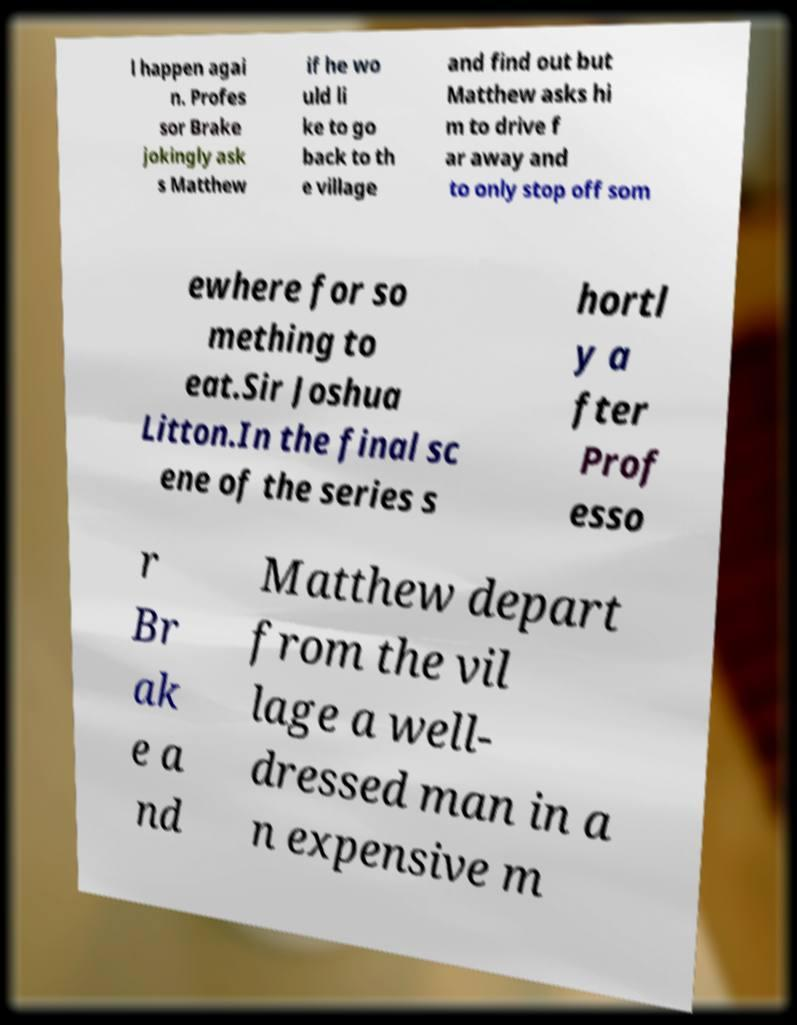There's text embedded in this image that I need extracted. Can you transcribe it verbatim? l happen agai n. Profes sor Brake jokingly ask s Matthew if he wo uld li ke to go back to th e village and find out but Matthew asks hi m to drive f ar away and to only stop off som ewhere for so mething to eat.Sir Joshua Litton.In the final sc ene of the series s hortl y a fter Prof esso r Br ak e a nd Matthew depart from the vil lage a well- dressed man in a n expensive m 